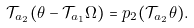<formula> <loc_0><loc_0><loc_500><loc_500>\mathcal { T } _ { a _ { 2 } } ( \theta - \mathcal { T } _ { a _ { 1 } } \Omega ) = p _ { 2 } ( \mathcal { T } _ { a _ { 2 } } \theta ) .</formula> 